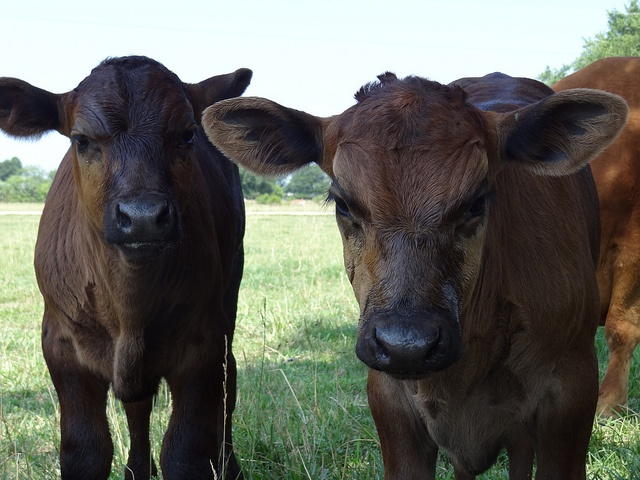Describe the objects in this image and their specific colors. I can see cow in white, black, and gray tones, cow in white, black, gray, and maroon tones, and cow in white, maroon, black, and gray tones in this image. 